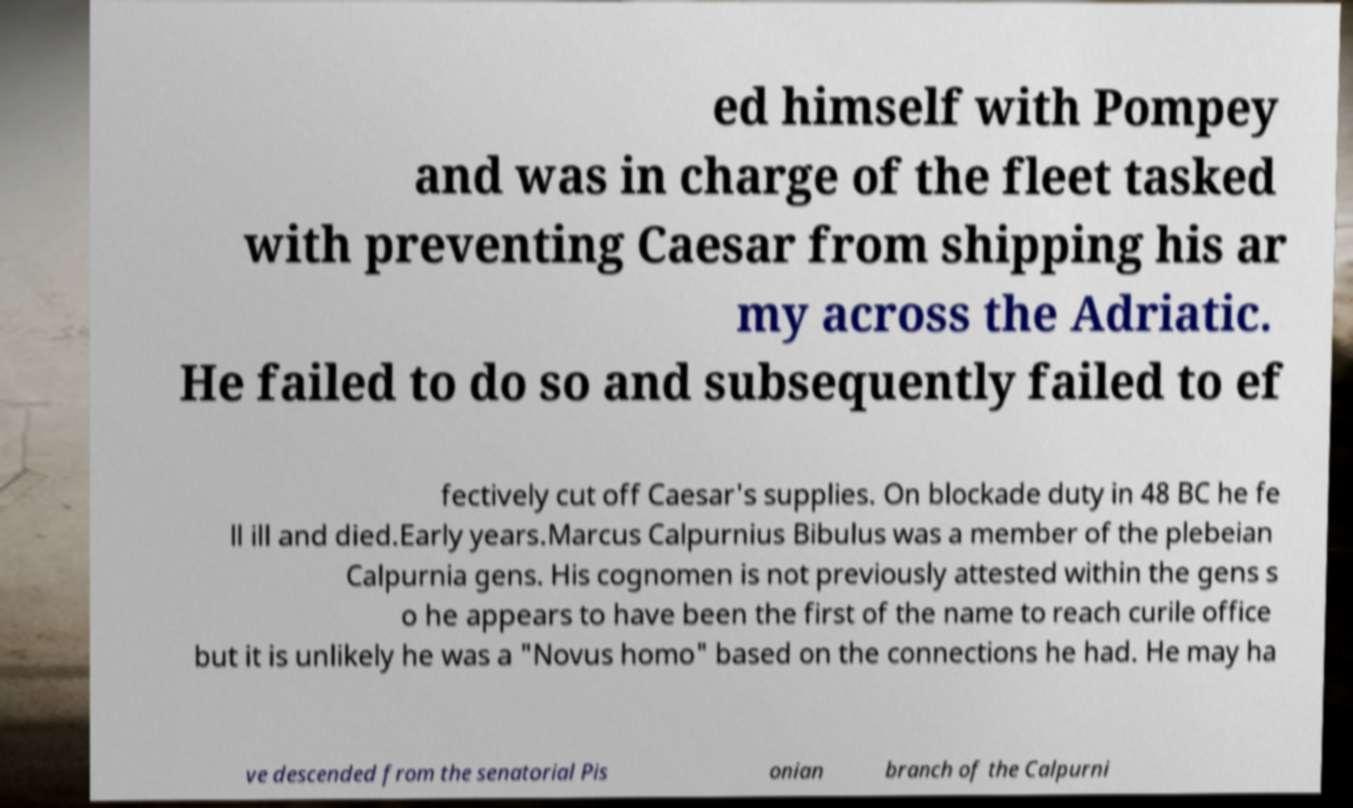Can you accurately transcribe the text from the provided image for me? ed himself with Pompey and was in charge of the fleet tasked with preventing Caesar from shipping his ar my across the Adriatic. He failed to do so and subsequently failed to ef fectively cut off Caesar's supplies. On blockade duty in 48 BC he fe ll ill and died.Early years.Marcus Calpurnius Bibulus was a member of the plebeian Calpurnia gens. His cognomen is not previously attested within the gens s o he appears to have been the first of the name to reach curile office but it is unlikely he was a "Novus homo" based on the connections he had. He may ha ve descended from the senatorial Pis onian branch of the Calpurni 